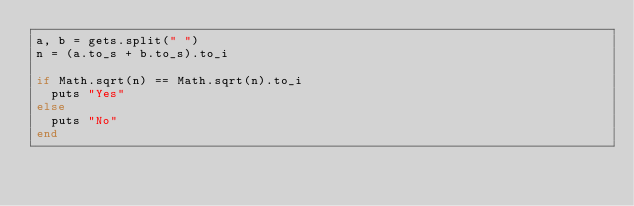<code> <loc_0><loc_0><loc_500><loc_500><_Ruby_>a, b = gets.split(" ")
n = (a.to_s + b.to_s).to_i

if Math.sqrt(n) == Math.sqrt(n).to_i
  puts "Yes"
else
  puts "No"
end</code> 